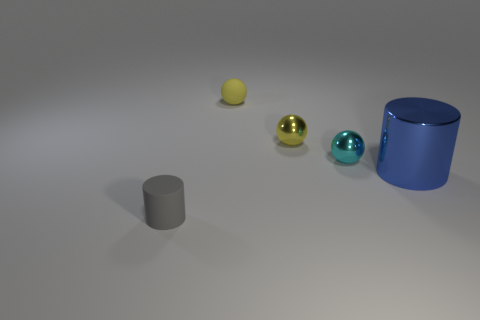Add 1 rubber cylinders. How many objects exist? 6 Subtract all cylinders. How many objects are left? 3 Add 1 gray rubber cylinders. How many gray rubber cylinders are left? 2 Add 5 big blue metal things. How many big blue metal things exist? 6 Subtract 0 red balls. How many objects are left? 5 Subtract all large blue cylinders. Subtract all blue shiny things. How many objects are left? 3 